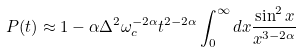Convert formula to latex. <formula><loc_0><loc_0><loc_500><loc_500>P ( t ) \approx 1 - \alpha \Delta ^ { 2 } \omega _ { c } ^ { - 2 \alpha } t ^ { 2 - 2 \alpha } \int _ { 0 } ^ { \infty } d x \frac { \sin ^ { 2 } x } { x ^ { 3 - 2 \alpha } }</formula> 